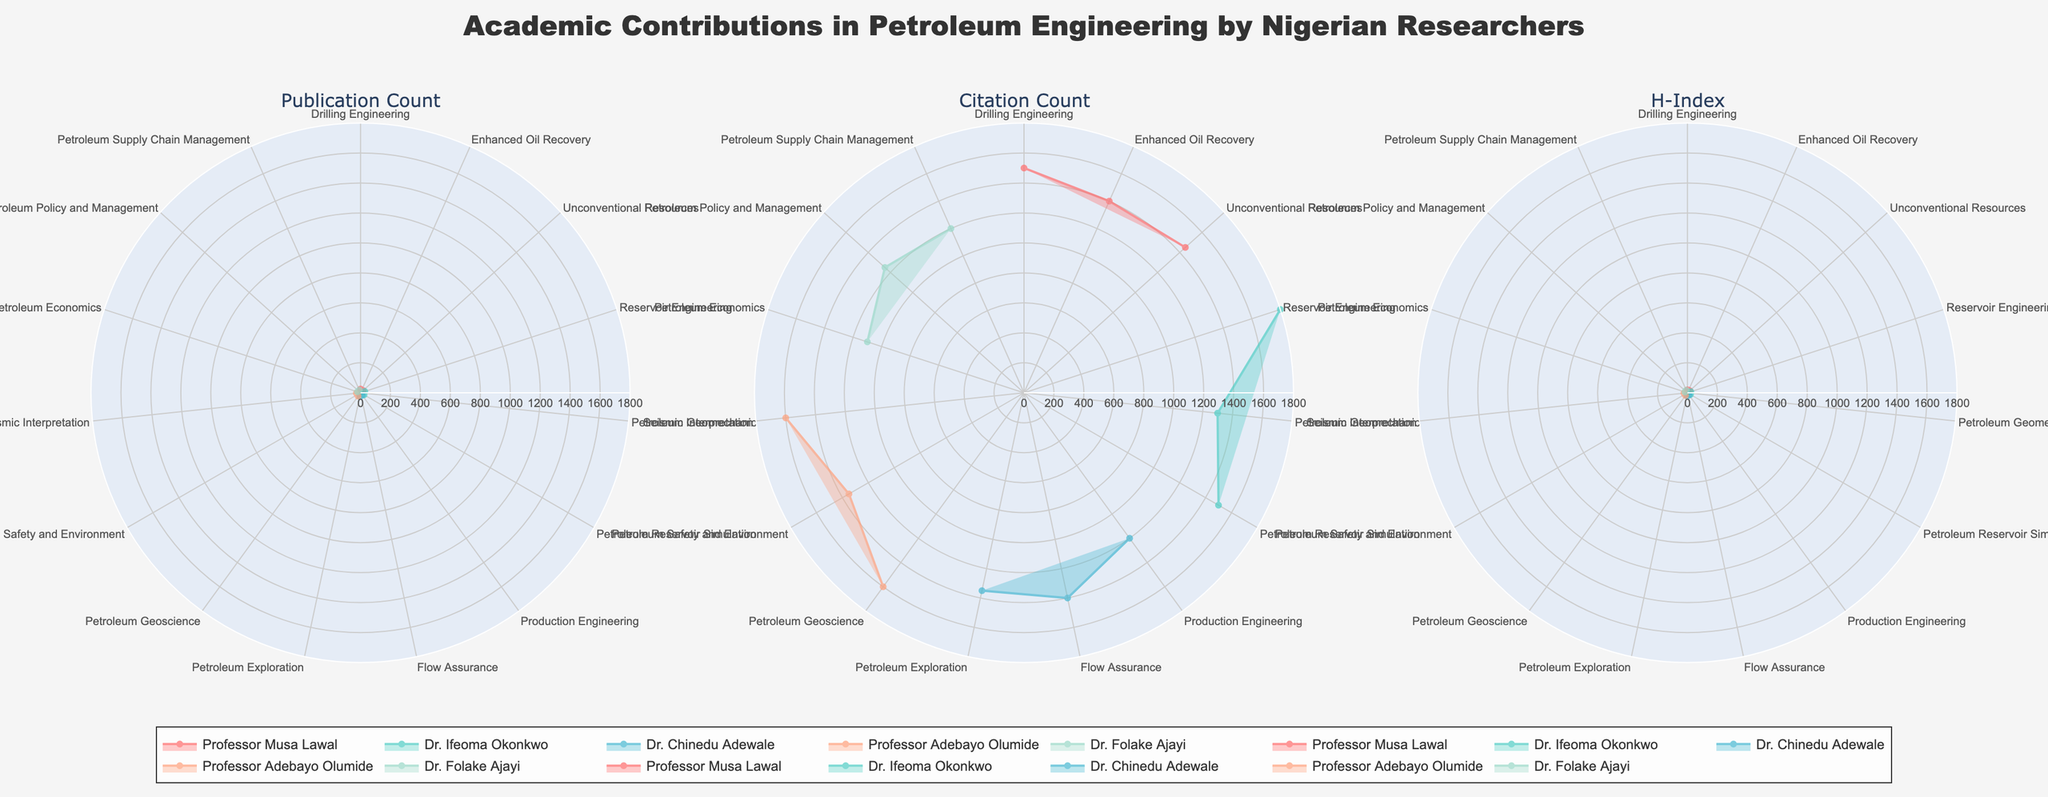What's the title of the figure? The title is found at the top center of the figure, indicated by larger text. It reads "Academic Contributions in Petroleum Engineering by Nigerian Researchers."
Answer: Academic Contributions in Petroleum Engineering by Nigerian Researchers How many sub-disciplines does Professor Musa Lawal contribute to? Each researcher's contributions are represented by different color-coded overlapping polygons within the sub-discipline axes. By counting the sections that belong to Professor Musa Lawal, it can be seen that he contributes to four sub-disciplines.
Answer: Four Which sub-discipline shows the highest publication count, and which researcher is associated with it? By examining the Publication Count plot, we look at the longest radial extension (highest value). This appears in the Reservoir Engineering sub-discipline for Dr. Ifeoma Okonkwo.
Answer: Reservoir Engineering and Dr. Ifeoma Okonkwo Which researcher has the highest H-Index in Flow Assurance? By focusing on the H-Index plot and locating the Flow Assurance axis, we can compare the values. Dr. Chinedu Adewale has the highest H-Index in this sub-discipline.
Answer: Dr. Chinedu Adewale How do the citation counts for Drilling Engineering differ between Professor Musa Lawal and Dr. Ifeoma Okonkwo? In the Citation Count plot, find the Drilling Engineering sub-discipline. Since Professor Musa Lawal is the only one listed under Drilling Engineering, there is no value for Dr. Ifeoma Okonkwo to compare. Hence, the difference cannot be observed.
Answer: Not applicable What is the average H-Index across all sub-disciplines for Professor Adebayo Olumide? Since Professor Adebayo Olumide has two contributions, Petroleum Geoscience (22) and Seismic Interpretation (24), we sum these values and divide by the number of sub-disciplines: (22 + 24) / 2 = 23.
Answer: 23 What's the difference in citation count between the sub-disciplines of Petroleum Safety and Environment and Unconventional Resources for Professor Musa Lawal? Locate these two sub-disciplines in the Citation Count plot. For Petroleum Safety and Environment, it's 1350, and for Unconventional Resources, it's 1450 for Professor Musa Lawal. The difference is 1450 - 1350 = 100.
Answer: 100 Who has made the highest contribution to Petroleum Policy and Management in terms of publication count, and what is the count? In the Publication Count plot, locate Petroleum Policy and Management. Dr. Folake Ajayi has the highest contribution with a count of 19.
Answer: Dr. Folake Ajayi, 19 